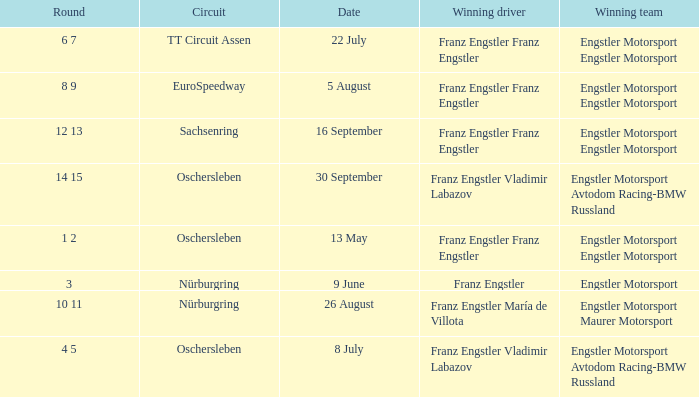What Round was the Winning Team Engstler Motorsport Maurer Motorsport? 10 11. Could you parse the entire table? {'header': ['Round', 'Circuit', 'Date', 'Winning driver', 'Winning team'], 'rows': [['6 7', 'TT Circuit Assen', '22 July', 'Franz Engstler Franz Engstler', 'Engstler Motorsport Engstler Motorsport'], ['8 9', 'EuroSpeedway', '5 August', 'Franz Engstler Franz Engstler', 'Engstler Motorsport Engstler Motorsport'], ['12 13', 'Sachsenring', '16 September', 'Franz Engstler Franz Engstler', 'Engstler Motorsport Engstler Motorsport'], ['14 15', 'Oschersleben', '30 September', 'Franz Engstler Vladimir Labazov', 'Engstler Motorsport Avtodom Racing-BMW Russland'], ['1 2', 'Oschersleben', '13 May', 'Franz Engstler Franz Engstler', 'Engstler Motorsport Engstler Motorsport'], ['3', 'Nürburgring', '9 June', 'Franz Engstler', 'Engstler Motorsport'], ['10 11', 'Nürburgring', '26 August', 'Franz Engstler María de Villota', 'Engstler Motorsport Maurer Motorsport'], ['4 5', 'Oschersleben', '8 July', 'Franz Engstler Vladimir Labazov', 'Engstler Motorsport Avtodom Racing-BMW Russland']]} 